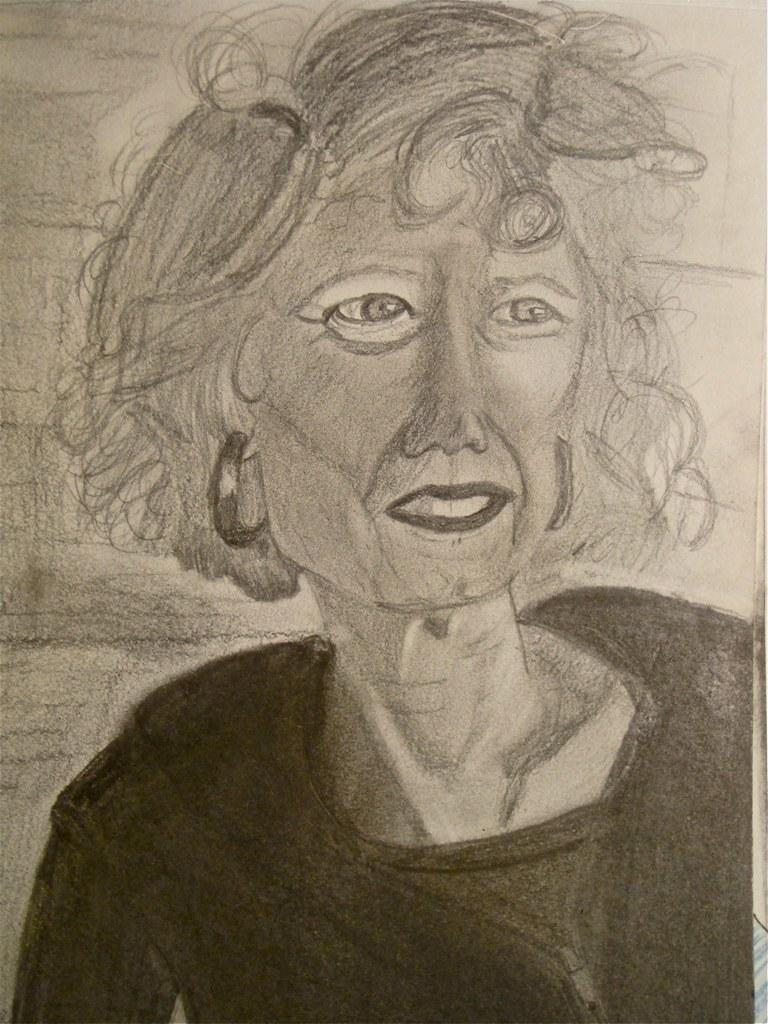What is depicted in the image? There is a drawing of a person in the image. What color is the background of the drawing? The background of the drawing is white in color. What type of calculator can be seen in the drawing? There is no calculator present in the drawing; it only features a person. Is there a birthday celebration happening in the drawing? There is no indication of a birthday celebration in the drawing; it only features a person and a white background. 